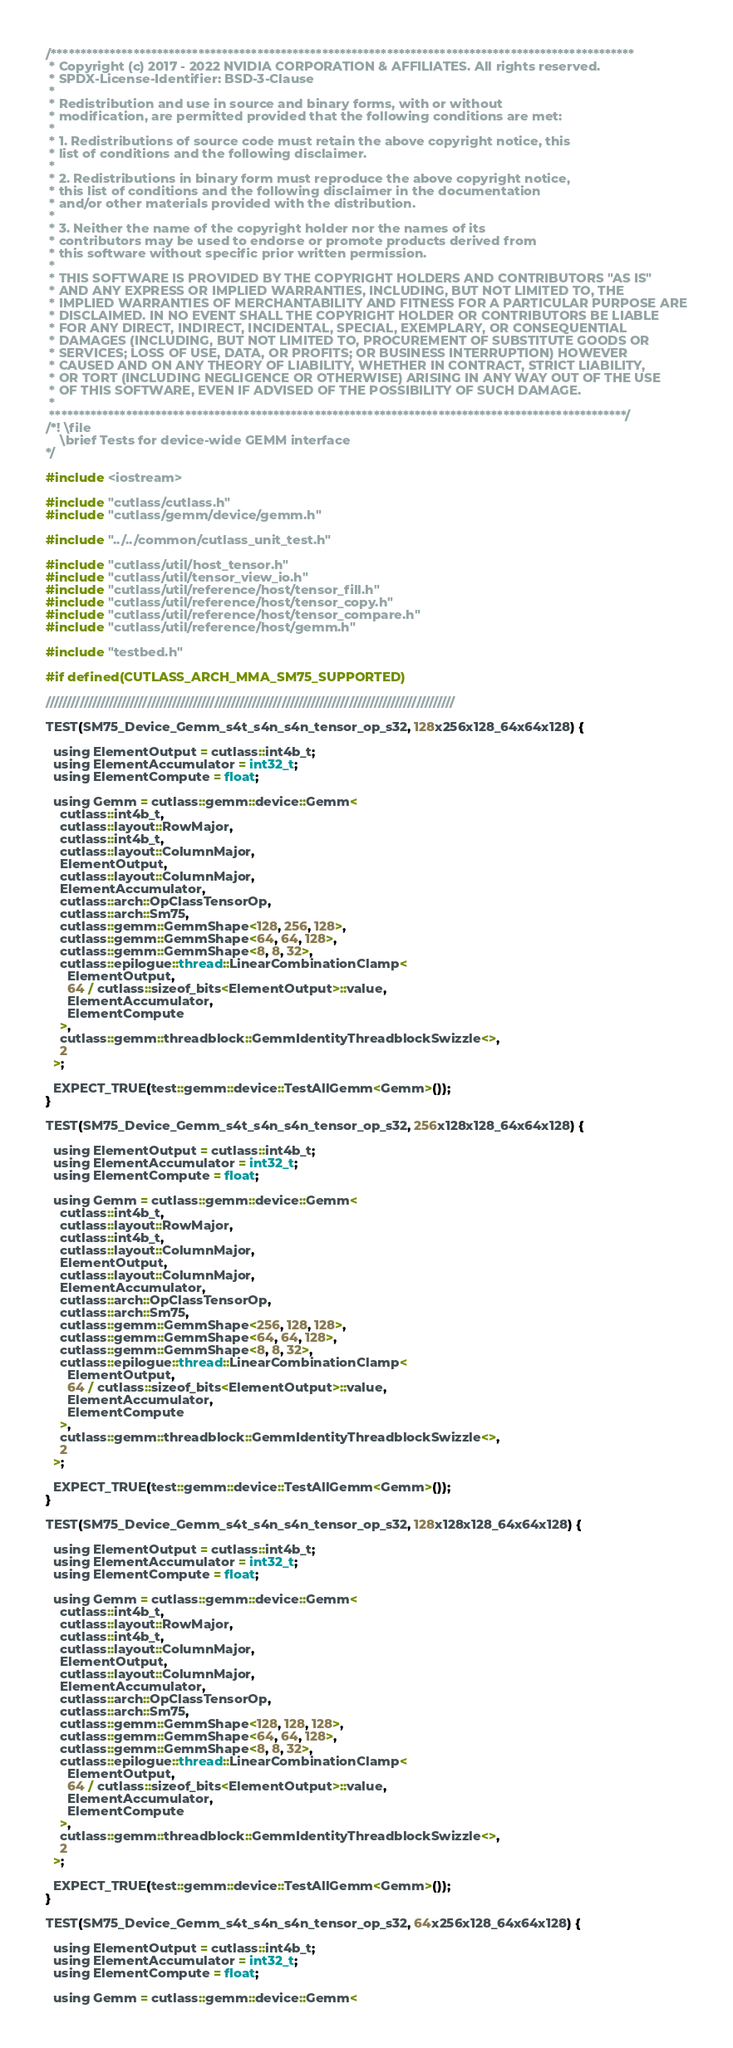<code> <loc_0><loc_0><loc_500><loc_500><_Cuda_>/***************************************************************************************************
 * Copyright (c) 2017 - 2022 NVIDIA CORPORATION & AFFILIATES. All rights reserved.
 * SPDX-License-Identifier: BSD-3-Clause
 *
 * Redistribution and use in source and binary forms, with or without
 * modification, are permitted provided that the following conditions are met:
 *
 * 1. Redistributions of source code must retain the above copyright notice, this
 * list of conditions and the following disclaimer.
 *
 * 2. Redistributions in binary form must reproduce the above copyright notice,
 * this list of conditions and the following disclaimer in the documentation
 * and/or other materials provided with the distribution.
 *
 * 3. Neither the name of the copyright holder nor the names of its
 * contributors may be used to endorse or promote products derived from
 * this software without specific prior written permission.
 *
 * THIS SOFTWARE IS PROVIDED BY THE COPYRIGHT HOLDERS AND CONTRIBUTORS "AS IS"
 * AND ANY EXPRESS OR IMPLIED WARRANTIES, INCLUDING, BUT NOT LIMITED TO, THE
 * IMPLIED WARRANTIES OF MERCHANTABILITY AND FITNESS FOR A PARTICULAR PURPOSE ARE
 * DISCLAIMED. IN NO EVENT SHALL THE COPYRIGHT HOLDER OR CONTRIBUTORS BE LIABLE
 * FOR ANY DIRECT, INDIRECT, INCIDENTAL, SPECIAL, EXEMPLARY, OR CONSEQUENTIAL
 * DAMAGES (INCLUDING, BUT NOT LIMITED TO, PROCUREMENT OF SUBSTITUTE GOODS OR
 * SERVICES; LOSS OF USE, DATA, OR PROFITS; OR BUSINESS INTERRUPTION) HOWEVER
 * CAUSED AND ON ANY THEORY OF LIABILITY, WHETHER IN CONTRACT, STRICT LIABILITY,
 * OR TORT (INCLUDING NEGLIGENCE OR OTHERWISE) ARISING IN ANY WAY OUT OF THE USE
 * OF THIS SOFTWARE, EVEN IF ADVISED OF THE POSSIBILITY OF SUCH DAMAGE.
 *
 **************************************************************************************************/
/*! \file
    \brief Tests for device-wide GEMM interface
*/

#include <iostream>

#include "cutlass/cutlass.h"
#include "cutlass/gemm/device/gemm.h"

#include "../../common/cutlass_unit_test.h"

#include "cutlass/util/host_tensor.h"
#include "cutlass/util/tensor_view_io.h"
#include "cutlass/util/reference/host/tensor_fill.h"
#include "cutlass/util/reference/host/tensor_copy.h"
#include "cutlass/util/reference/host/tensor_compare.h"
#include "cutlass/util/reference/host/gemm.h"

#include "testbed.h"

#if defined(CUTLASS_ARCH_MMA_SM75_SUPPORTED)

/////////////////////////////////////////////////////////////////////////////////////////////////

TEST(SM75_Device_Gemm_s4t_s4n_s4n_tensor_op_s32, 128x256x128_64x64x128) {

  using ElementOutput = cutlass::int4b_t;
  using ElementAccumulator = int32_t;
  using ElementCompute = float;

  using Gemm = cutlass::gemm::device::Gemm<
    cutlass::int4b_t,
    cutlass::layout::RowMajor,
    cutlass::int4b_t,
    cutlass::layout::ColumnMajor,
    ElementOutput,
    cutlass::layout::ColumnMajor,
    ElementAccumulator,
    cutlass::arch::OpClassTensorOp,
    cutlass::arch::Sm75,
    cutlass::gemm::GemmShape<128, 256, 128>,
    cutlass::gemm::GemmShape<64, 64, 128>,
    cutlass::gemm::GemmShape<8, 8, 32>,
    cutlass::epilogue::thread::LinearCombinationClamp<
      ElementOutput,
      64 / cutlass::sizeof_bits<ElementOutput>::value,
      ElementAccumulator,
      ElementCompute
    >,
    cutlass::gemm::threadblock::GemmIdentityThreadblockSwizzle<>,
    2
  >;

  EXPECT_TRUE(test::gemm::device::TestAllGemm<Gemm>());
}

TEST(SM75_Device_Gemm_s4t_s4n_s4n_tensor_op_s32, 256x128x128_64x64x128) {

  using ElementOutput = cutlass::int4b_t;
  using ElementAccumulator = int32_t;
  using ElementCompute = float;

  using Gemm = cutlass::gemm::device::Gemm<
    cutlass::int4b_t,
    cutlass::layout::RowMajor,
    cutlass::int4b_t,
    cutlass::layout::ColumnMajor,
    ElementOutput,
    cutlass::layout::ColumnMajor,
    ElementAccumulator,
    cutlass::arch::OpClassTensorOp,
    cutlass::arch::Sm75,
    cutlass::gemm::GemmShape<256, 128, 128>,
    cutlass::gemm::GemmShape<64, 64, 128>,
    cutlass::gemm::GemmShape<8, 8, 32>,
    cutlass::epilogue::thread::LinearCombinationClamp<
      ElementOutput,
      64 / cutlass::sizeof_bits<ElementOutput>::value,
      ElementAccumulator,
      ElementCompute
    >,
    cutlass::gemm::threadblock::GemmIdentityThreadblockSwizzle<>,
    2
  >;

  EXPECT_TRUE(test::gemm::device::TestAllGemm<Gemm>());
}

TEST(SM75_Device_Gemm_s4t_s4n_s4n_tensor_op_s32, 128x128x128_64x64x128) {

  using ElementOutput = cutlass::int4b_t;
  using ElementAccumulator = int32_t;
  using ElementCompute = float;

  using Gemm = cutlass::gemm::device::Gemm<
    cutlass::int4b_t,
    cutlass::layout::RowMajor,
    cutlass::int4b_t,
    cutlass::layout::ColumnMajor,
    ElementOutput,
    cutlass::layout::ColumnMajor,
    ElementAccumulator,
    cutlass::arch::OpClassTensorOp,
    cutlass::arch::Sm75,
    cutlass::gemm::GemmShape<128, 128, 128>,
    cutlass::gemm::GemmShape<64, 64, 128>,
    cutlass::gemm::GemmShape<8, 8, 32>,
    cutlass::epilogue::thread::LinearCombinationClamp<
      ElementOutput,
      64 / cutlass::sizeof_bits<ElementOutput>::value,
      ElementAccumulator,
      ElementCompute
    >,
    cutlass::gemm::threadblock::GemmIdentityThreadblockSwizzle<>,
    2
  >;

  EXPECT_TRUE(test::gemm::device::TestAllGemm<Gemm>());
}

TEST(SM75_Device_Gemm_s4t_s4n_s4n_tensor_op_s32, 64x256x128_64x64x128) {

  using ElementOutput = cutlass::int4b_t;
  using ElementAccumulator = int32_t;
  using ElementCompute = float;

  using Gemm = cutlass::gemm::device::Gemm<</code> 